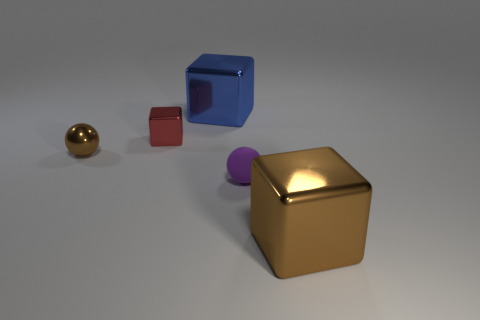Subtract all small red cubes. How many cubes are left? 2 Add 2 small brown objects. How many objects exist? 7 Subtract all red cubes. How many cubes are left? 2 Subtract all blocks. How many objects are left? 2 Subtract 1 blocks. How many blocks are left? 2 Subtract all cyan blocks. How many green spheres are left? 0 Subtract all large red cylinders. Subtract all big metallic objects. How many objects are left? 3 Add 2 big blue metal things. How many big blue metal things are left? 3 Add 4 yellow metal cylinders. How many yellow metal cylinders exist? 4 Subtract 0 gray blocks. How many objects are left? 5 